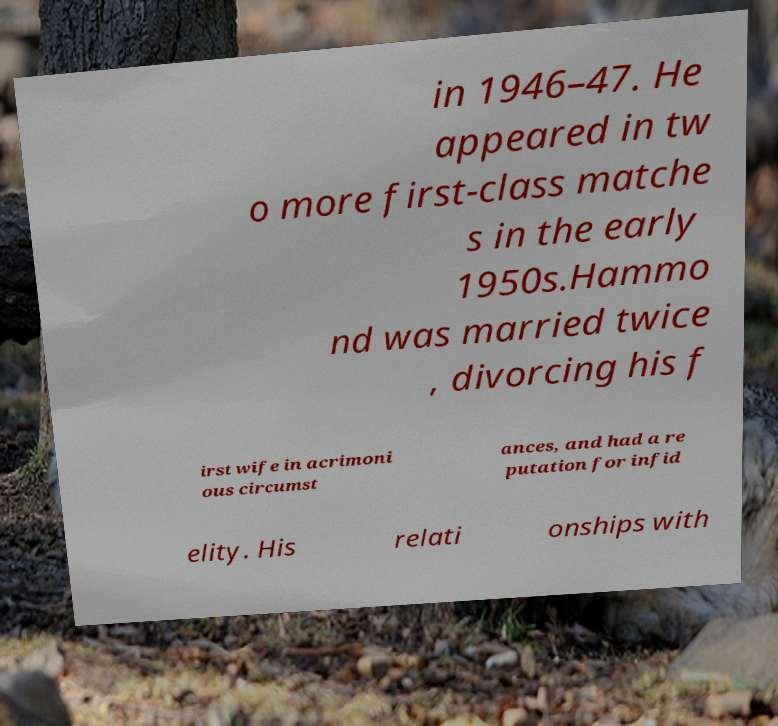What messages or text are displayed in this image? I need them in a readable, typed format. in 1946–47. He appeared in tw o more first-class matche s in the early 1950s.Hammo nd was married twice , divorcing his f irst wife in acrimoni ous circumst ances, and had a re putation for infid elity. His relati onships with 